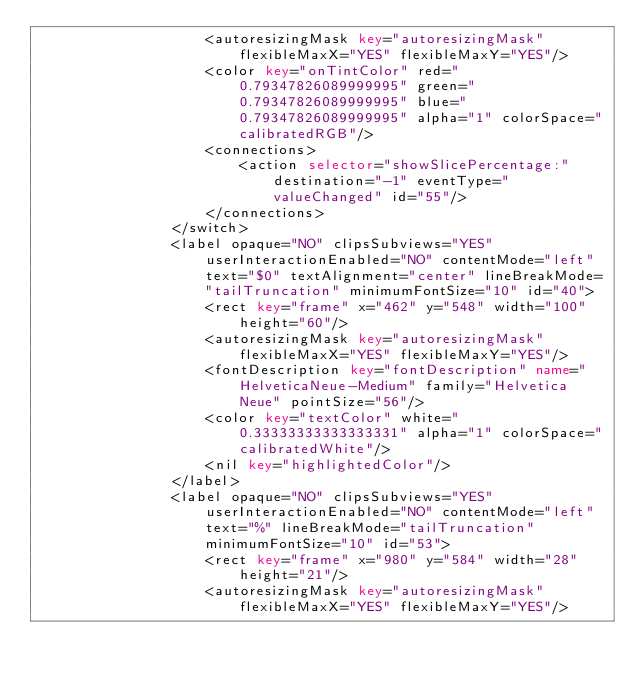<code> <loc_0><loc_0><loc_500><loc_500><_XML_>                    <autoresizingMask key="autoresizingMask" flexibleMaxX="YES" flexibleMaxY="YES"/>
                    <color key="onTintColor" red="0.79347826089999995" green="0.79347826089999995" blue="0.79347826089999995" alpha="1" colorSpace="calibratedRGB"/>
                    <connections>
                        <action selector="showSlicePercentage:" destination="-1" eventType="valueChanged" id="55"/>
                    </connections>
                </switch>
                <label opaque="NO" clipsSubviews="YES" userInteractionEnabled="NO" contentMode="left" text="$0" textAlignment="center" lineBreakMode="tailTruncation" minimumFontSize="10" id="40">
                    <rect key="frame" x="462" y="548" width="100" height="60"/>
                    <autoresizingMask key="autoresizingMask" flexibleMaxX="YES" flexibleMaxY="YES"/>
                    <fontDescription key="fontDescription" name="HelveticaNeue-Medium" family="Helvetica Neue" pointSize="56"/>
                    <color key="textColor" white="0.33333333333333331" alpha="1" colorSpace="calibratedWhite"/>
                    <nil key="highlightedColor"/>
                </label>
                <label opaque="NO" clipsSubviews="YES" userInteractionEnabled="NO" contentMode="left" text="%" lineBreakMode="tailTruncation" minimumFontSize="10" id="53">
                    <rect key="frame" x="980" y="584" width="28" height="21"/>
                    <autoresizingMask key="autoresizingMask" flexibleMaxX="YES" flexibleMaxY="YES"/></code> 